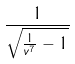<formula> <loc_0><loc_0><loc_500><loc_500>\frac { 1 } { \sqrt { \frac { 1 } { v ^ { 7 } } - 1 } }</formula> 